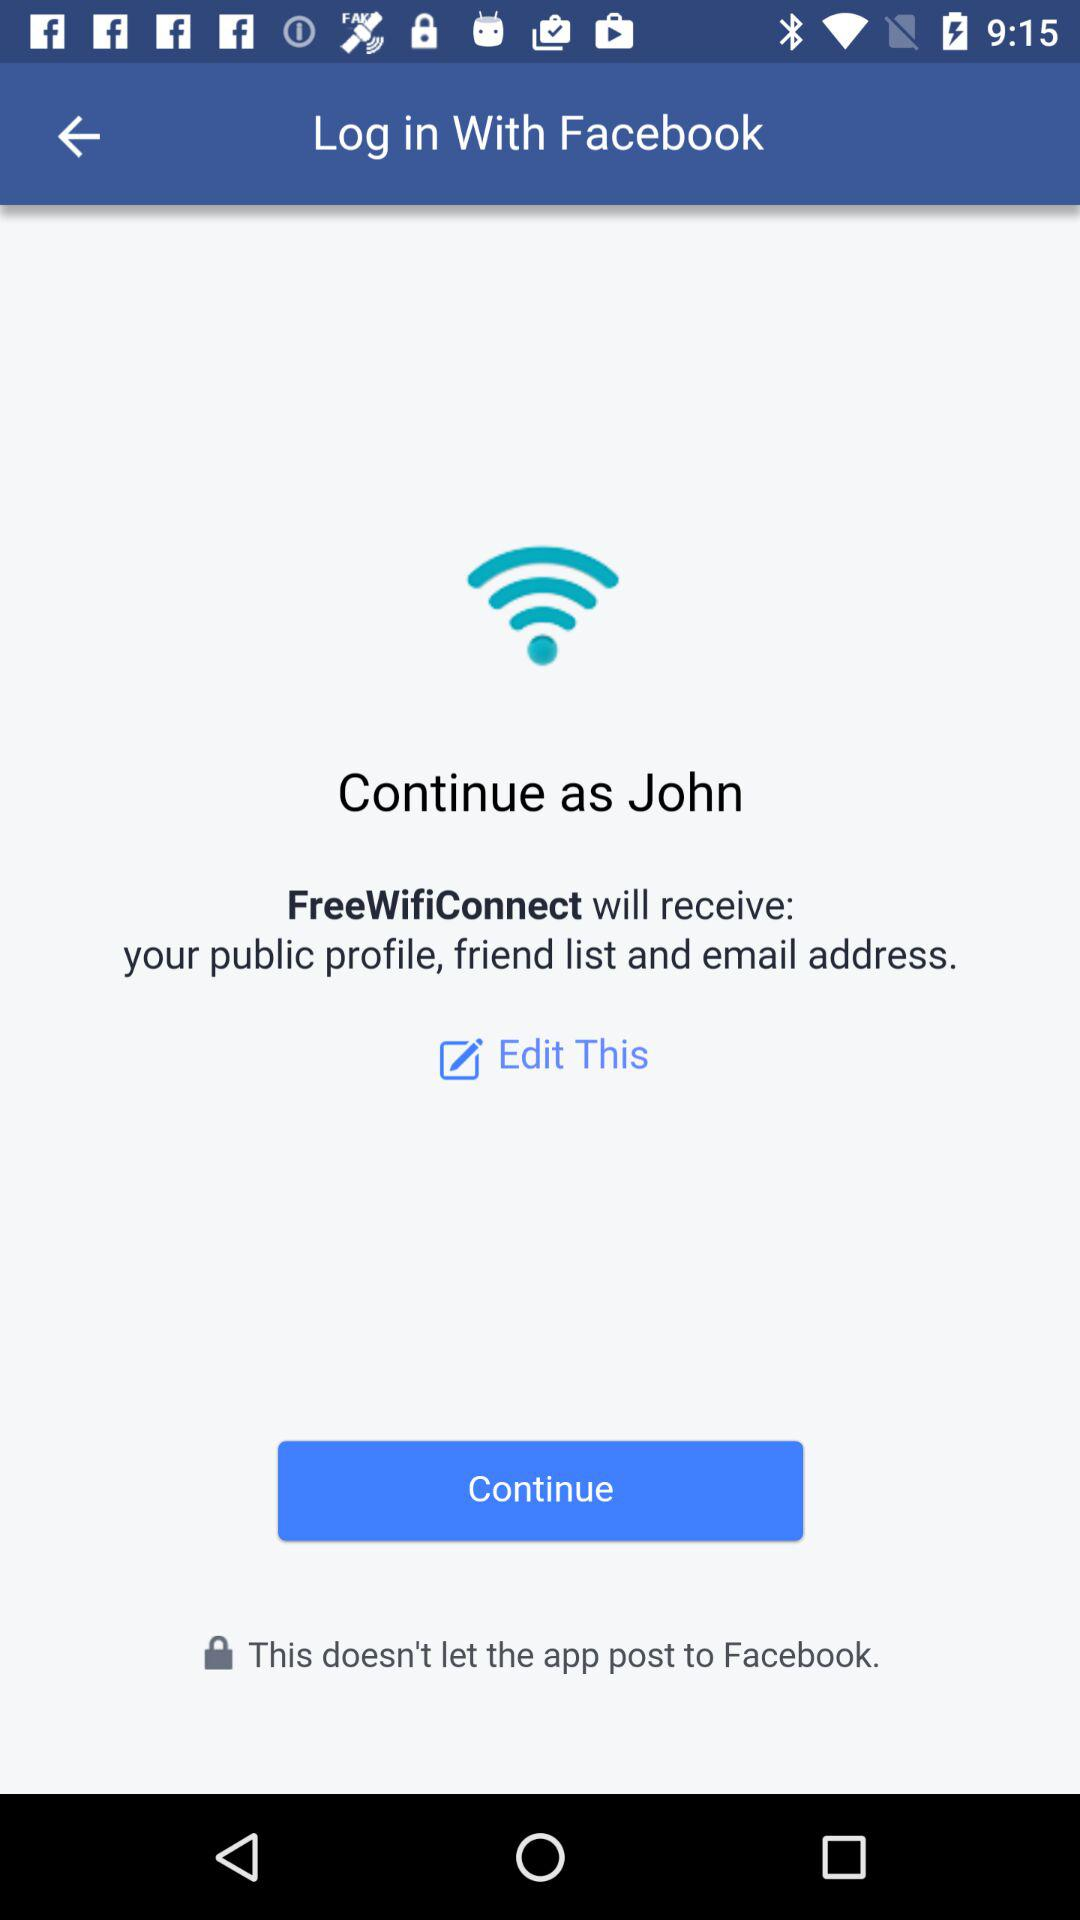What application will receive my public profile, email address and friend list? The application "FreeWifiConnect" will receive your public profile, email address and friend list. 